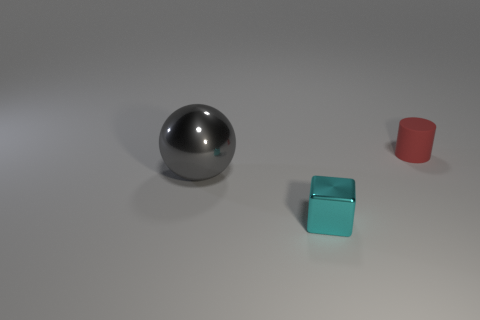Add 2 small brown blocks. How many objects exist? 5 Subtract 1 blocks. How many blocks are left? 0 Subtract 0 brown cylinders. How many objects are left? 3 Subtract all cylinders. How many objects are left? 2 Subtract all purple cylinders. How many purple blocks are left? 0 Subtract all small rubber things. Subtract all big metallic things. How many objects are left? 1 Add 2 large gray shiny balls. How many large gray shiny balls are left? 3 Add 2 things. How many things exist? 5 